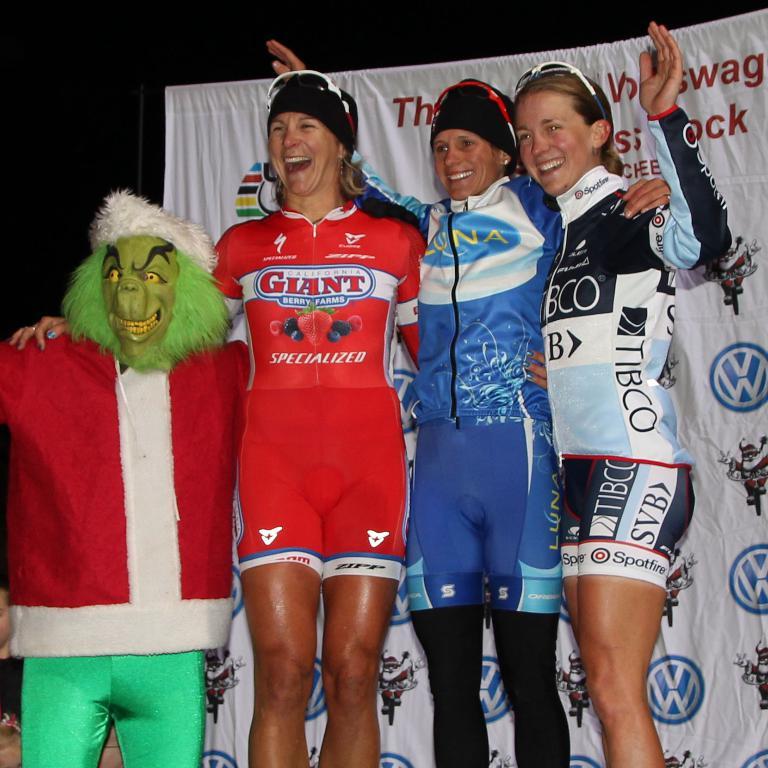What is the bicycle brand front center on the cyclist's red jersey?
Make the answer very short. Giant. 